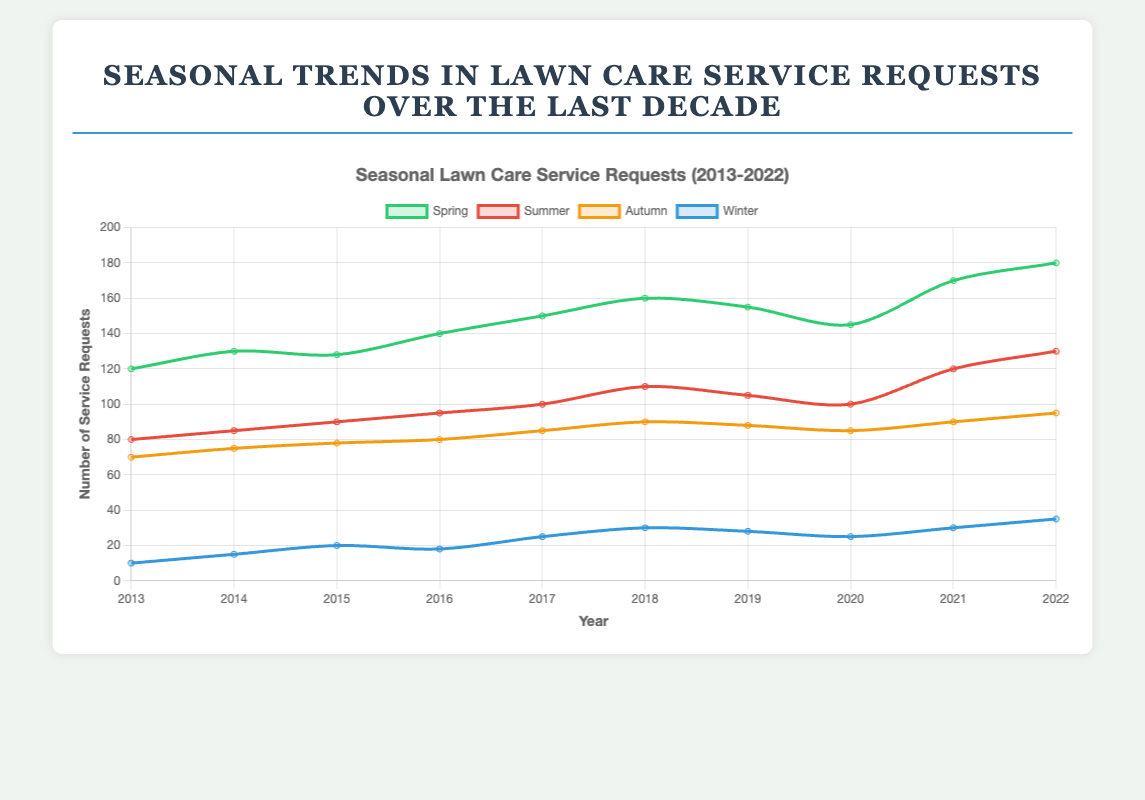What's the trend for Spring lawn care service requests over the last decade? To observe the trend for Spring, look at the green line's general direction from 2013 to 2022. It shows an increasing pattern. In 2013, the number starts at 120 and continuously rises to 180 in 2022, with minor fluctuations.
Answer: Increasing trend Which season had the most significant increase in service requests from 2013 to 2022? Compare the values in 2013 and 2022 for each season. Spring increased from 120 to 180 (60), Summer from 80 to 130 (50), Autumn from 70 to 95 (25), and Winter from 10 to 35 (25). Spring had the most significant increase of 60.
Answer: Spring How did Winter service requests in 2022 compare to Summer service requests in 2017? Look at the values for Winter in 2022 (35) and Summer in 2017 (100). Compare these two values.
Answer: Winter 2022 is lower by 65 What's the average number of service requests in Autumn over the decade? Sum the values for Autumn (70 + 75 + 78 + 80 + 85 + 90 + 88 + 85 + 90 + 95 = 836). Divide by the number of years (10), so 836 / 10.
Answer: 83.6 In which years did Spring have more service requests than Summer? Compare Spring and Summer values year by year. In 2013 (120 > 80), 2014 (130 > 85), 2015 (128 > 90), 2016 (140 > 95), 2017 (150 > 100), 2018 (160 > 110), 2019 (155 > 105), and 2022 (180 > 130), Spring had more requests than Summer.
Answer: 2013, 2014, 2015, 2016, 2017, 2018, 2019, 2022 Which year's data shows the closest number of service requests for all four seasons? Compare the differences between values in each year and find the year with the smallest differences. In 2020, the values are 145 (Spring), 100 (Summer), 85 (Autumn), 25 (Winter). The maximum difference is between Spring and Winter (145 - 25 = 120) whereas the other years have even larger differences.
Answer: 2020 When did Summer service requests first exceed 100? Check the Summer values year by year until one exceeds 100. The first instance is in 2018 with 110 requests.
Answer: 2018 What's the combined total of Spring and Winter requests in 2015? Spring requests in 2015 are 128, and Winter requests are 20. Adding these together: 128 + 20.
Answer: 148 How much did Autumn service requests fluctuate over the decade? Calculate the range by finding the difference between the maximum and minimum values of Autumn. The maximum is 95 (2022) and the minimum is 70 (2013). So, 95 - 70.
Answer: 25 Is there any year where each season had fewer than 100 service requests? Check each year's values for all four seasons. In 2013, all values are (Spring: 120, Summer: 80, Autumn: 70, Winter: 10) hence Spring is over 100. In 2014, all values are (Spring: 130, Summer: 85, Autumn: 75, Winter: 15), again Spring is over 100. As such, check each year and no year fulfills this condition.
Answer: No 